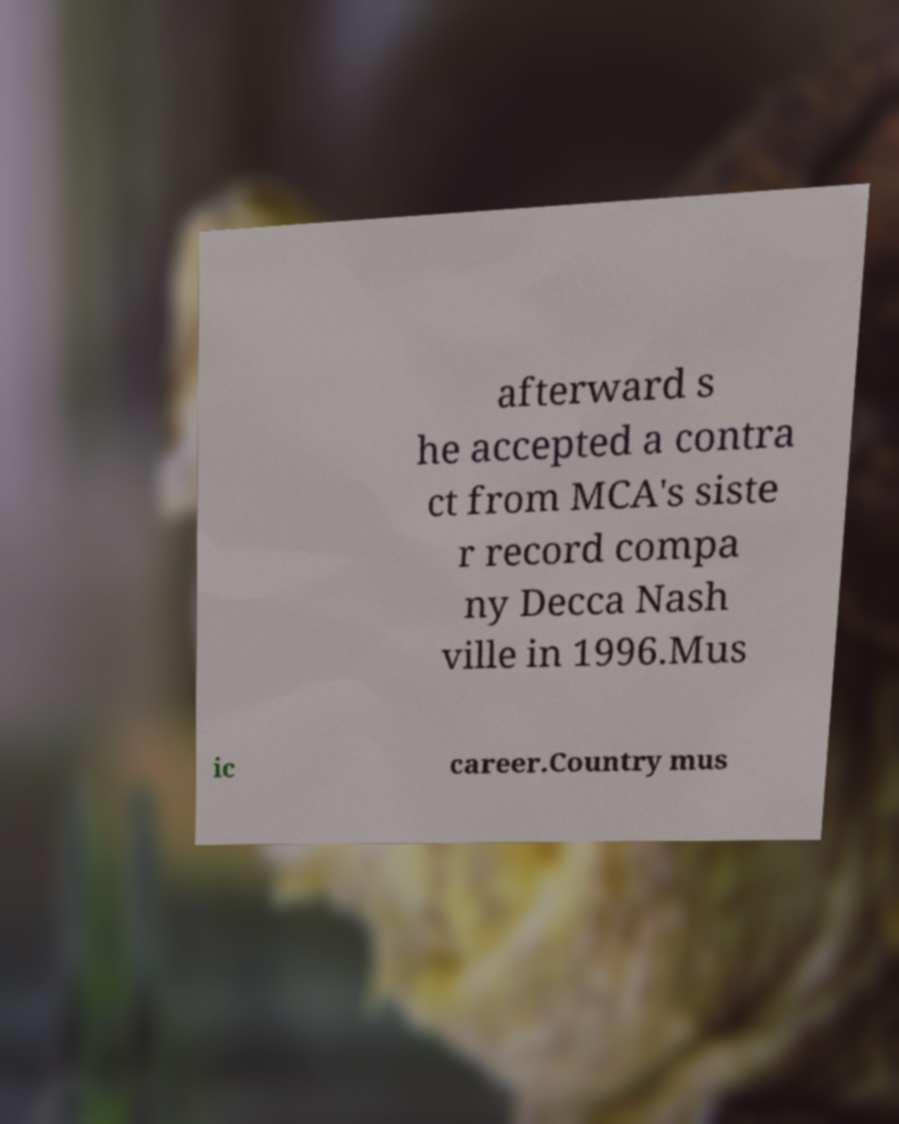For documentation purposes, I need the text within this image transcribed. Could you provide that? afterward s he accepted a contra ct from MCA's siste r record compa ny Decca Nash ville in 1996.Mus ic career.Country mus 